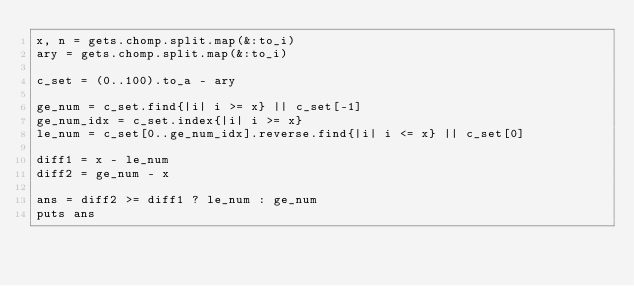<code> <loc_0><loc_0><loc_500><loc_500><_Ruby_>x, n = gets.chomp.split.map(&:to_i)
ary = gets.chomp.split.map(&:to_i)

c_set = (0..100).to_a - ary

ge_num = c_set.find{|i| i >= x} || c_set[-1]
ge_num_idx = c_set.index{|i| i >= x}
le_num = c_set[0..ge_num_idx].reverse.find{|i| i <= x} || c_set[0]

diff1 = x - le_num
diff2 = ge_num - x

ans = diff2 >= diff1 ? le_num : ge_num
puts ans

</code> 